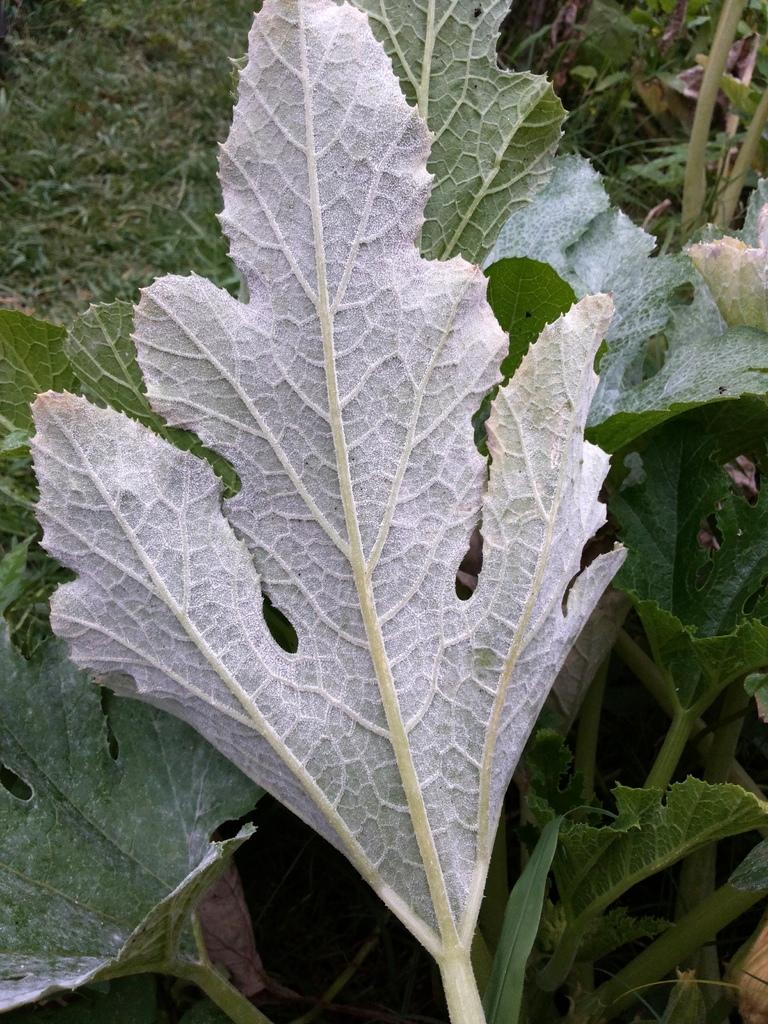What is located in the middle of the image? There are leaves in the middle of the image. What type of terrain can be seen at the top left side of the image? There is a grassy land visible at the top left side of the image. What type of mist can be seen surrounding the leaves in the image? There is no mist present in the image; it only features leaves and grassy land. 